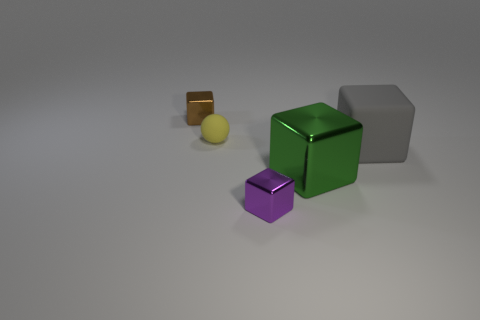Is there a pattern to the arrangement of the objects? Looking at the arrangement, there doesn't seem to be a deliberate pattern. The objects are scattered without an obvious order, each positioned independently from the others. Their placement on the surface creates a casual and random composition you might find in a setting where objects have been placed down temporarily without organization. 